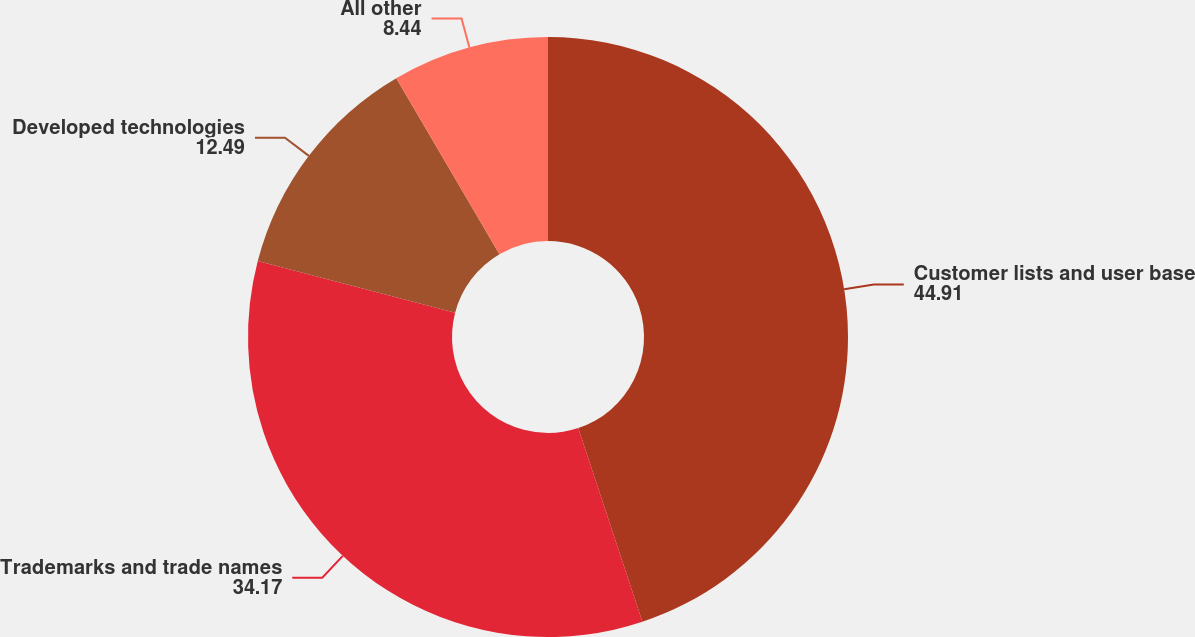Convert chart to OTSL. <chart><loc_0><loc_0><loc_500><loc_500><pie_chart><fcel>Customer lists and user base<fcel>Trademarks and trade names<fcel>Developed technologies<fcel>All other<nl><fcel>44.91%<fcel>34.17%<fcel>12.49%<fcel>8.44%<nl></chart> 